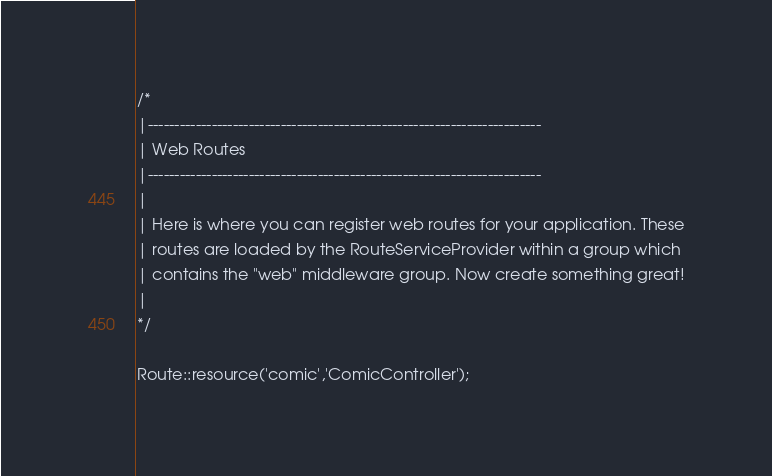Convert code to text. <code><loc_0><loc_0><loc_500><loc_500><_PHP_>/*
|--------------------------------------------------------------------------
| Web Routes
|--------------------------------------------------------------------------
|
| Here is where you can register web routes for your application. These
| routes are loaded by the RouteServiceProvider within a group which
| contains the "web" middleware group. Now create something great!
|
*/

Route::resource('comic','ComicController');</code> 